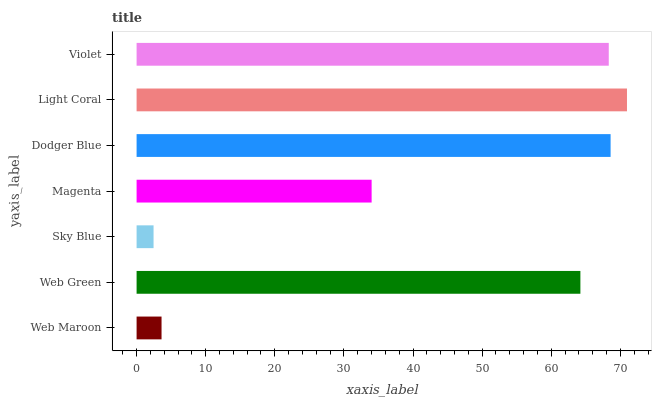Is Sky Blue the minimum?
Answer yes or no. Yes. Is Light Coral the maximum?
Answer yes or no. Yes. Is Web Green the minimum?
Answer yes or no. No. Is Web Green the maximum?
Answer yes or no. No. Is Web Green greater than Web Maroon?
Answer yes or no. Yes. Is Web Maroon less than Web Green?
Answer yes or no. Yes. Is Web Maroon greater than Web Green?
Answer yes or no. No. Is Web Green less than Web Maroon?
Answer yes or no. No. Is Web Green the high median?
Answer yes or no. Yes. Is Web Green the low median?
Answer yes or no. Yes. Is Dodger Blue the high median?
Answer yes or no. No. Is Violet the low median?
Answer yes or no. No. 